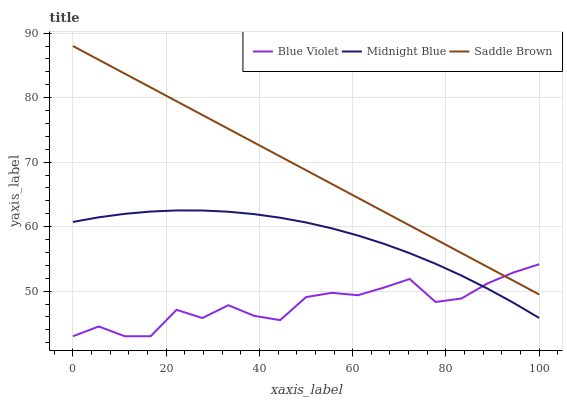Does Saddle Brown have the minimum area under the curve?
Answer yes or no. No. Does Blue Violet have the maximum area under the curve?
Answer yes or no. No. Is Blue Violet the smoothest?
Answer yes or no. No. Is Saddle Brown the roughest?
Answer yes or no. No. Does Saddle Brown have the lowest value?
Answer yes or no. No. Does Blue Violet have the highest value?
Answer yes or no. No. Is Midnight Blue less than Saddle Brown?
Answer yes or no. Yes. Is Saddle Brown greater than Midnight Blue?
Answer yes or no. Yes. Does Midnight Blue intersect Saddle Brown?
Answer yes or no. No. 